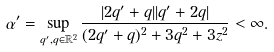<formula> <loc_0><loc_0><loc_500><loc_500>\alpha ^ { \prime } = \sup _ { q ^ { \prime } , q \in \mathbb { R } ^ { 2 } } \frac { | 2 q ^ { \prime } + q | | q ^ { \prime } + 2 q | } { ( 2 q ^ { \prime } + q ) ^ { 2 } + 3 q ^ { 2 } + 3 z ^ { 2 } } < \infty .</formula> 